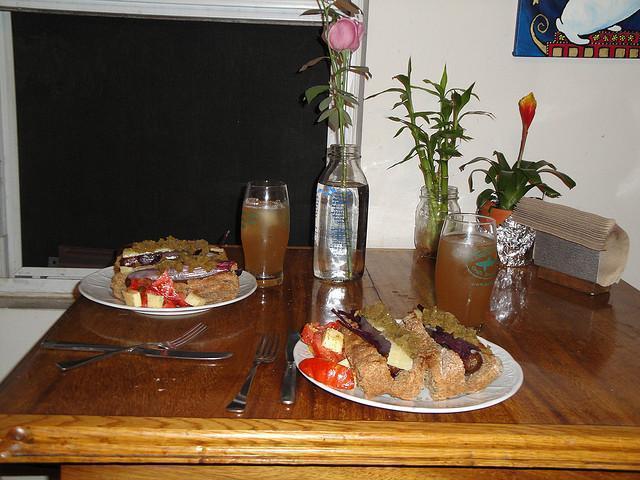What are the items in the brown and grey receptacle for?
Answer the question by selecting the correct answer among the 4 following choices and explain your choice with a short sentence. The answer should be formatted with the following format: `Answer: choice
Rationale: rationale.`
Options: Washing, stirring, wiping, eating. Answer: wiping.
Rationale: The receptacle has tissue. 